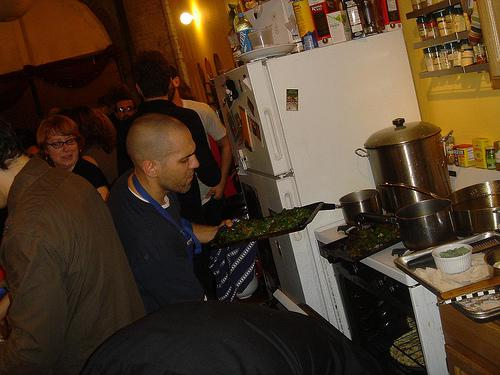Question: who is in the picture?
Choices:
A. A group of people is in the picture.
B. A single man.
C. R2d2.
D. Snow White.
Answer with the letter. Answer: A Question: what is going on in the picture?
Choices:
A. People working.
B. Dinosaurs roaming.
C. People are having a small party.
D. Parade.
Answer with the letter. Answer: C Question: what color is the refrigerator?
Choices:
A. Black.
B. It is white.
C. Silver.
D. Red.
Answer with the letter. Answer: B Question: where was this picture taken?
Choices:
A. Restaurant.
B. Hotel.
C. Hospital.
D. It was taken in someone's house.
Answer with the letter. Answer: D 